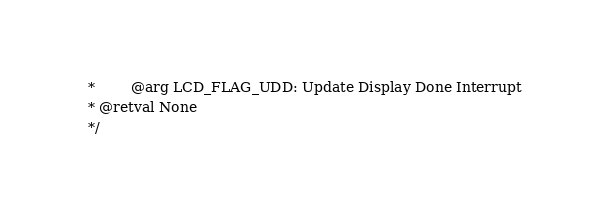Convert code to text. <code><loc_0><loc_0><loc_500><loc_500><_C_>  *        @arg LCD_FLAG_UDD: Update Display Done Interrupt
  * @retval None
  */</code> 